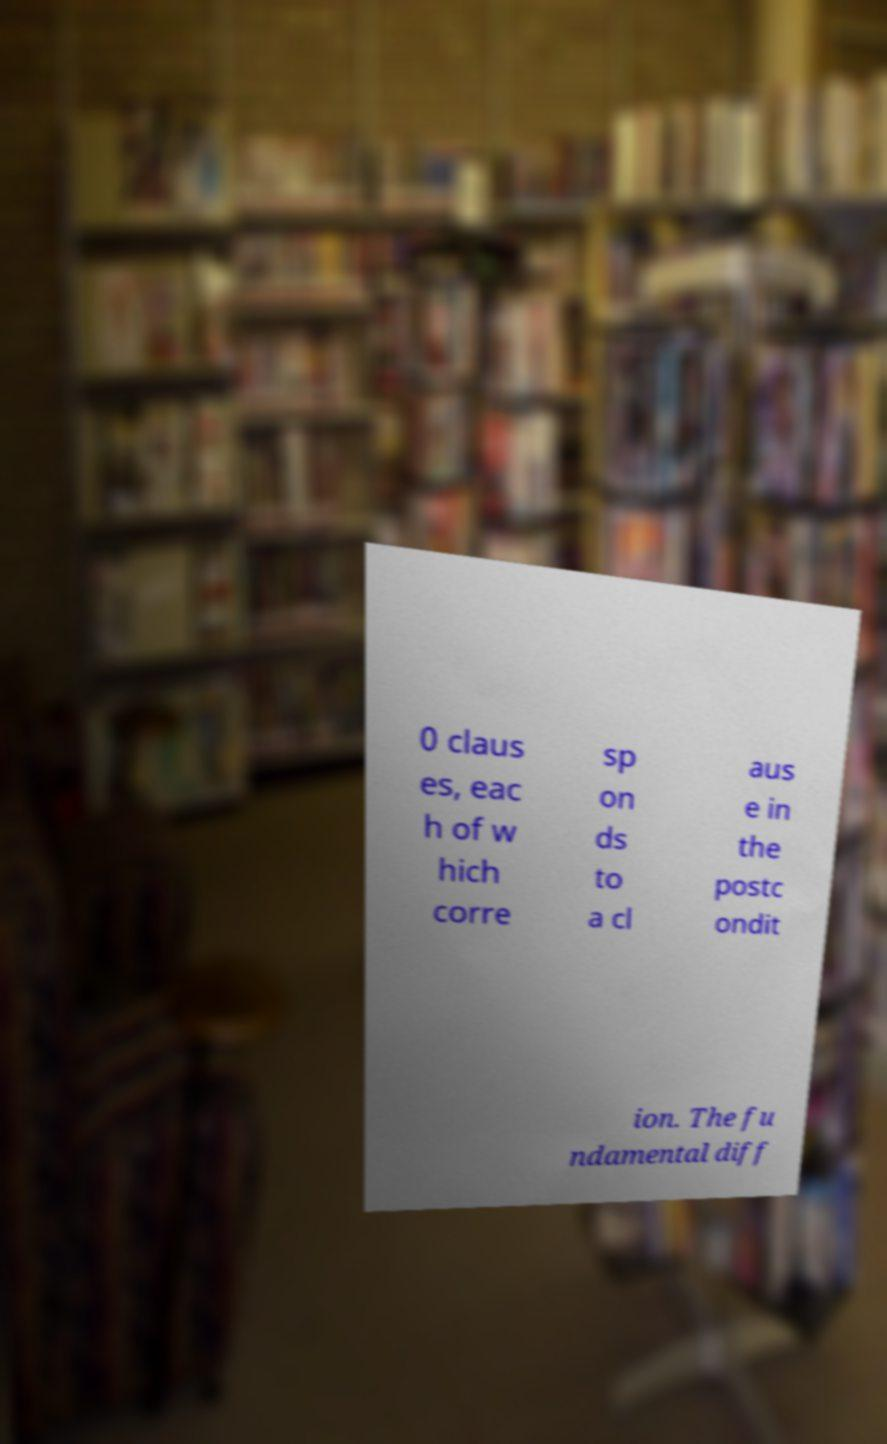Please identify and transcribe the text found in this image. 0 claus es, eac h of w hich corre sp on ds to a cl aus e in the postc ondit ion. The fu ndamental diff 